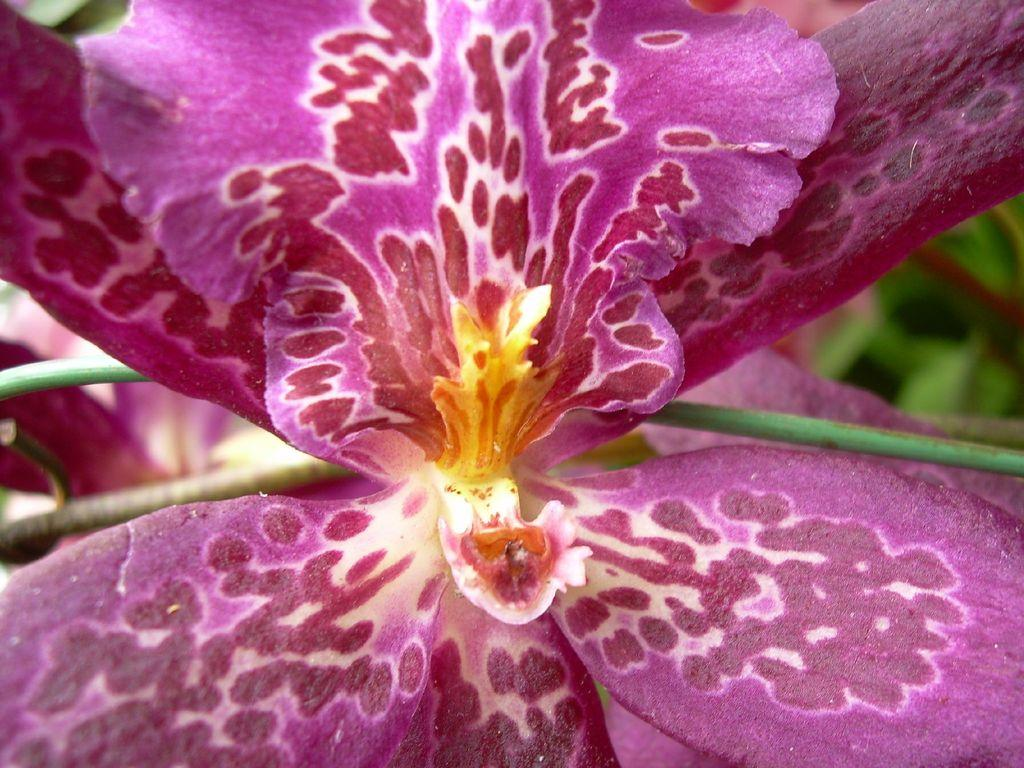What is present in the image? There is a plant in the image. What can be observed about the plant's flower? The plant has a pink flower. Can you describe the flower's appearance? The flower has petals. How many cars are parked next to the plant in the image? There are no cars present in the image; it only features a plant with a pink flower. Are there any friends or women visible in the image? There is no mention of friends or women in the image; it only features a plant with a pink flower. 